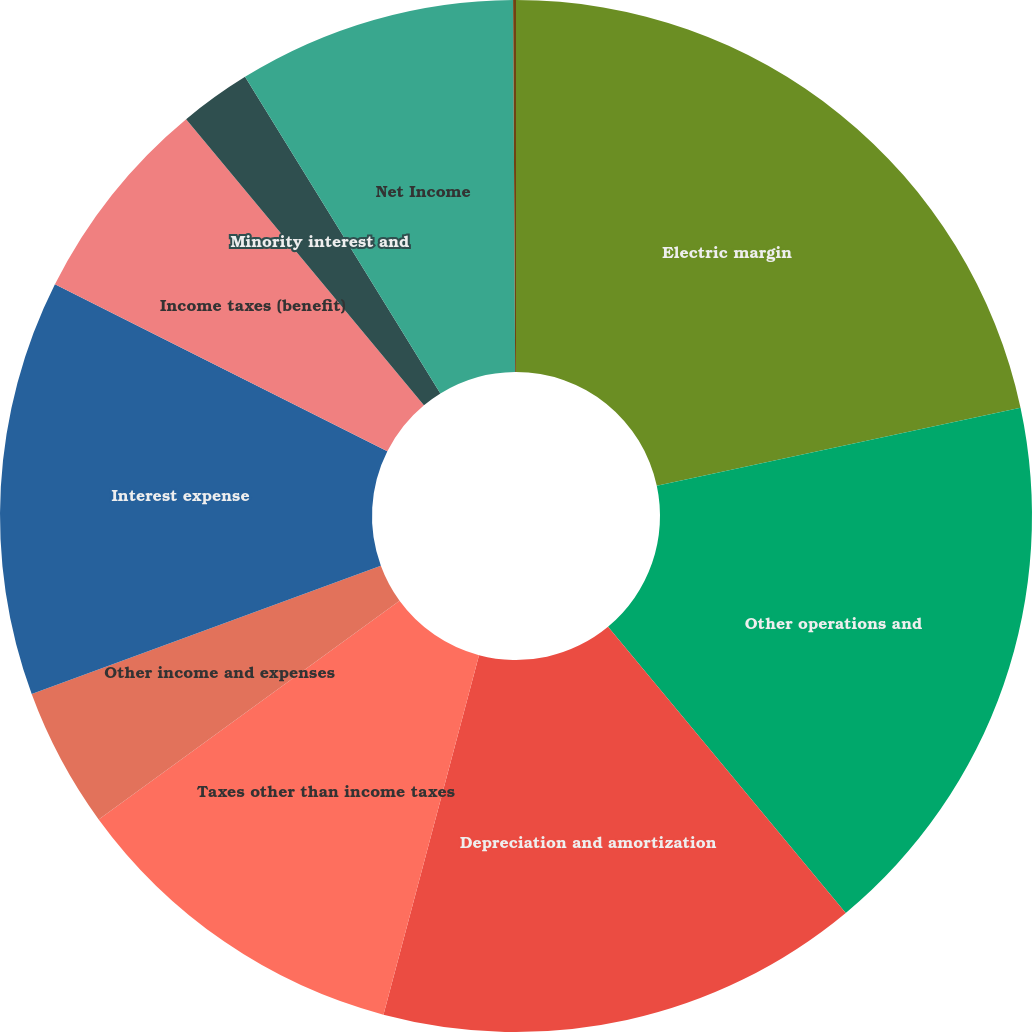Convert chart to OTSL. <chart><loc_0><loc_0><loc_500><loc_500><pie_chart><fcel>Electric margin<fcel>Other operations and<fcel>Depreciation and amortization<fcel>Taxes other than income taxes<fcel>Other income and expenses<fcel>Interest expense<fcel>Income taxes (benefit)<fcel>Minority interest and<fcel>Net Income<fcel>Other revenue<nl><fcel>21.64%<fcel>17.33%<fcel>15.17%<fcel>10.86%<fcel>4.4%<fcel>13.02%<fcel>6.55%<fcel>2.24%<fcel>8.71%<fcel>0.09%<nl></chart> 